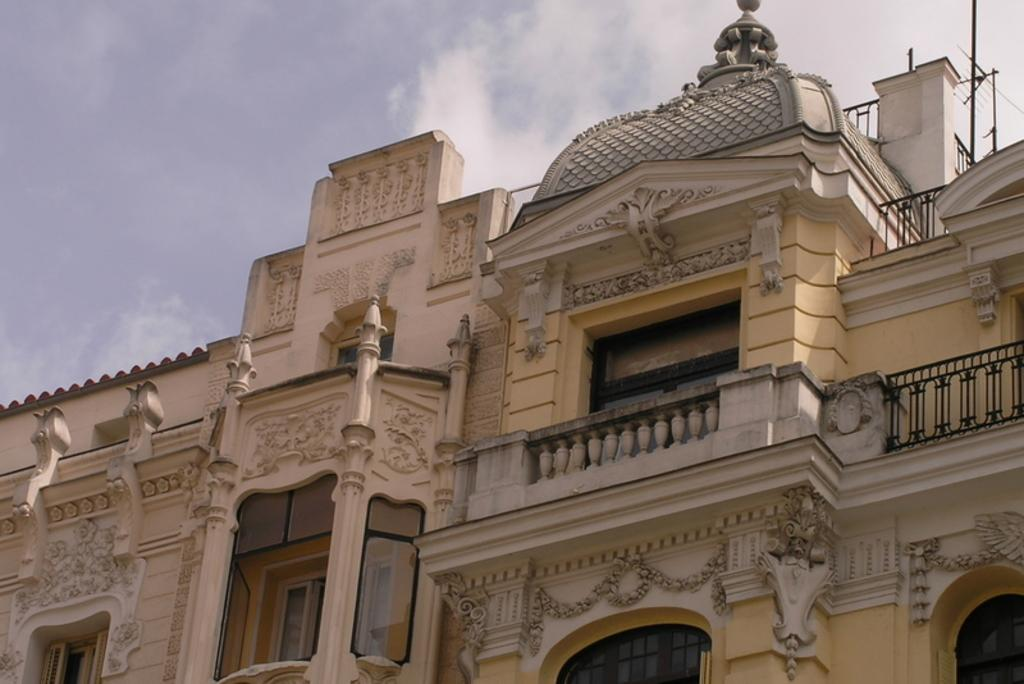What type of structure is present in the image? There is a building in the image. What features can be observed on the building? The building has windows, railings, walls with designs, and roofs. Are there any additional objects in the image besides the building? Yes, there are poles in the image. What can be seen in the sky in the image? The sky is visible at the top of the image, and there are clouds in the sky. Where is the basin located in the image? There is no basin present in the image. What type of stage is set up in the image? There is no stage present in the image. 